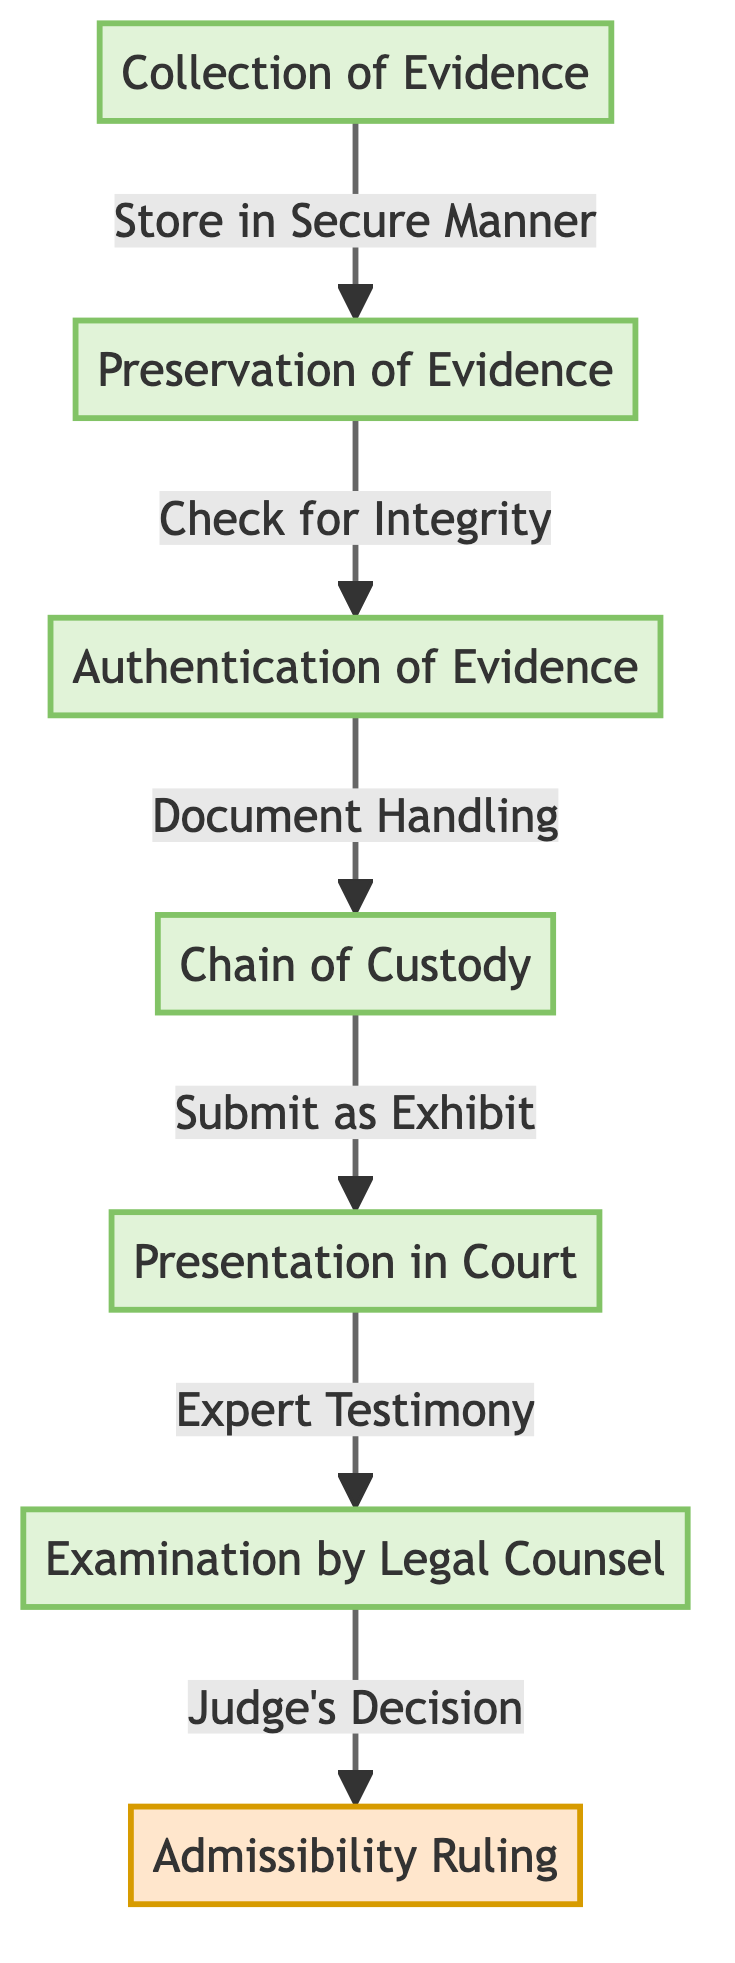What is the first step in admitting digital evidence? The first step in the diagram is labeled "Collection of Evidence." This is the starting point of the process and sets the foundation for all subsequent steps.
Answer: Collection of Evidence How many processes are involved in the diagram? The diagram has six processes, which include "Collection of Evidence," "Preservation of Evidence," "Authentication of Evidence," "Chain of Custody," "Presentation in Court," and "Examination by Legal Counsel." Counting these gives us a total of six.
Answer: Six What is the last process before the judge's decision? The last process before the judge's decision is "Examination by Legal Counsel." This step occurs immediately prior to the judge making a decision regarding the admissibility of the evidence.
Answer: Examination by Legal Counsel What connects the "Preservation of Evidence" to "Authentication of Evidence"? The connection between "Preservation of Evidence" and "Authentication of Evidence" is labeled "Check for Integrity." This indicates that ensuring the integrity of the evidence is crucial before it can be authenticated.
Answer: Check for Integrity Which step requires "Expert Testimony"? The step that requires "Expert Testimony" is "Presentation in Court." This indicates that the evidence must be presented with the assistance of an expert who can explain its relevance and validity to the court.
Answer: Presentation in Court What is the decision point in the process? The decision point in the diagram is labeled "Admissibility Ruling." This step signifies the moment when the judge evaluates all prior processes and decides whether the digital evidence can be admitted in court.
Answer: Admissibility Ruling How does the "Chain of Custody" relate to evidence handling? The "Chain of Custody" is related to evidence handling through the connection labeled "Document Handling," indicating that proper documentation of how the evidence is handled is necessary to maintain its integrity.
Answer: Document Handling What happens after "Submit as Exhibit"? After "Submit as Exhibit," the next step is "Examination by Legal Counsel." This means that once evidence is submitted, it will be examined by lawyers to prepare for the court proceedings.
Answer: Examination by Legal Counsel Which step directly follows "Check for Integrity"? The step that directly follows "Check for Integrity" is "Authentication of Evidence." This means that after the evidence is preserved and its integrity checked, it can then be authenticated for use in court.
Answer: Authentication of Evidence 